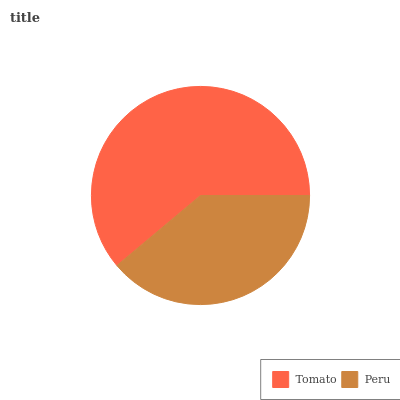Is Peru the minimum?
Answer yes or no. Yes. Is Tomato the maximum?
Answer yes or no. Yes. Is Peru the maximum?
Answer yes or no. No. Is Tomato greater than Peru?
Answer yes or no. Yes. Is Peru less than Tomato?
Answer yes or no. Yes. Is Peru greater than Tomato?
Answer yes or no. No. Is Tomato less than Peru?
Answer yes or no. No. Is Tomato the high median?
Answer yes or no. Yes. Is Peru the low median?
Answer yes or no. Yes. Is Peru the high median?
Answer yes or no. No. Is Tomato the low median?
Answer yes or no. No. 